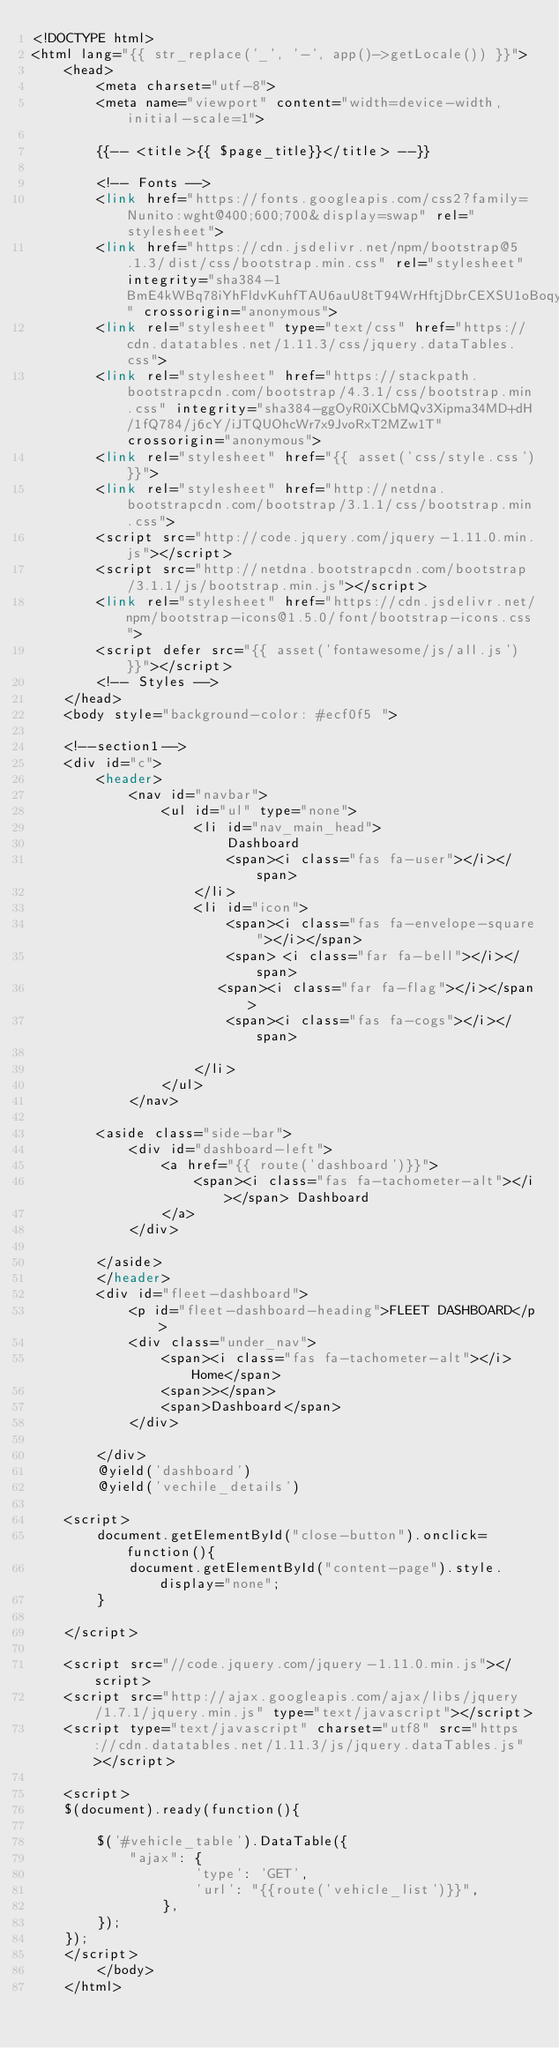Convert code to text. <code><loc_0><loc_0><loc_500><loc_500><_PHP_><!DOCTYPE html>
<html lang="{{ str_replace('_', '-', app()->getLocale()) }}">
    <head>
        <meta charset="utf-8">
        <meta name="viewport" content="width=device-width, initial-scale=1">

        {{-- <title>{{ $page_title}}</title> --}}

        <!-- Fonts -->
        <link href="https://fonts.googleapis.com/css2?family=Nunito:wght@400;600;700&display=swap" rel="stylesheet">
        <link href="https://cdn.jsdelivr.net/npm/bootstrap@5.1.3/dist/css/bootstrap.min.css" rel="stylesheet" integrity="sha384-1BmE4kWBq78iYhFldvKuhfTAU6auU8tT94WrHftjDbrCEXSU1oBoqyl2QvZ6jIW3" crossorigin="anonymous">
        <link rel="stylesheet" type="text/css" href="https://cdn.datatables.net/1.11.3/css/jquery.dataTables.css">
        <link rel="stylesheet" href="https://stackpath.bootstrapcdn.com/bootstrap/4.3.1/css/bootstrap.min.css" integrity="sha384-ggOyR0iXCbMQv3Xipma34MD+dH/1fQ784/j6cY/iJTQUOhcWr7x9JvoRxT2MZw1T" crossorigin="anonymous">
        <link rel="stylesheet" href="{{ asset('css/style.css')}}">
        <link rel="stylesheet" href="http://netdna.bootstrapcdn.com/bootstrap/3.1.1/css/bootstrap.min.css">
        <script src="http://code.jquery.com/jquery-1.11.0.min.js"></script>
        <script src="http://netdna.bootstrapcdn.com/bootstrap/3.1.1/js/bootstrap.min.js"></script>
        <link rel="stylesheet" href="https://cdn.jsdelivr.net/npm/bootstrap-icons@1.5.0/font/bootstrap-icons.css">
        <script defer src="{{ asset('fontawesome/js/all.js') }}"></script> 
        <!-- Styles -->
    </head>
    <body style="background-color: #ecf0f5 ">
    
    <!--section1-->
    <div id="c">
        <header>
            <nav id="navbar">
                <ul id="ul" type="none">
                    <li id="nav_main_head">
                        Dashboard
                        <span><i class="fas fa-user"></i></span>
                    </li>
                    <li id="icon">
                        <span><i class="fas fa-envelope-square"></i></span>
                        <span> <i class="far fa-bell"></i></span>
                       <span><i class="far fa-flag"></i></span>
                        <span><i class="fas fa-cogs"></i></span>
                        
                    </li>
                </ul>
            </nav>
        
        <aside class="side-bar">
            <div id="dashboard-left">
                <a href="{{ route('dashboard')}}">
                    <span><i class="fas fa-tachometer-alt"></i></span> Dashboard
                </a>
            </div>
            
        </aside>
        </header>
        <div id="fleet-dashboard">
            <p id="fleet-dashboard-heading">FLEET DASHBOARD</p>
            <div class="under_nav">
                <span><i class="fas fa-tachometer-alt"></i>Home</span>
                <span>></span>
                <span>Dashboard</span>
            </div>
        
        </div>
        @yield('dashboard')
        @yield('vechile_details')

    <script>
        document.getElementById("close-button").onclick=function(){
            document.getElementById("content-page").style.display="none";
        }
    
    </script>
    
    <script src="//code.jquery.com/jquery-1.11.0.min.js"></script>
    <script src="http://ajax.googleapis.com/ajax/libs/jquery/1.7.1/jquery.min.js" type="text/javascript"></script>
    <script type="text/javascript" charset="utf8" src="https://cdn.datatables.net/1.11.3/js/jquery.dataTables.js"></script>
    
    <script>
    $(document).ready(function(){
    
        $('#vehicle_table').DataTable({
            "ajax": {
                    'type': 'GET',
                    'url': "{{route('vehicle_list')}}",
                },
        });
    });
    </script>
        </body>
    </html>
    </code> 